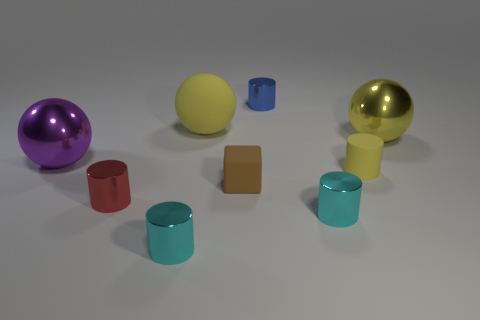Subtract 1 cylinders. How many cylinders are left? 4 Subtract all yellow rubber balls. How many balls are left? 2 Subtract all red cylinders. How many cylinders are left? 4 Subtract all green cylinders. Subtract all yellow spheres. How many cylinders are left? 5 Add 1 blue spheres. How many objects exist? 10 Subtract all balls. How many objects are left? 6 Add 8 big rubber balls. How many big rubber balls are left? 9 Add 8 red balls. How many red balls exist? 8 Subtract 1 brown blocks. How many objects are left? 8 Subtract all blue metal cylinders. Subtract all cyan cylinders. How many objects are left? 6 